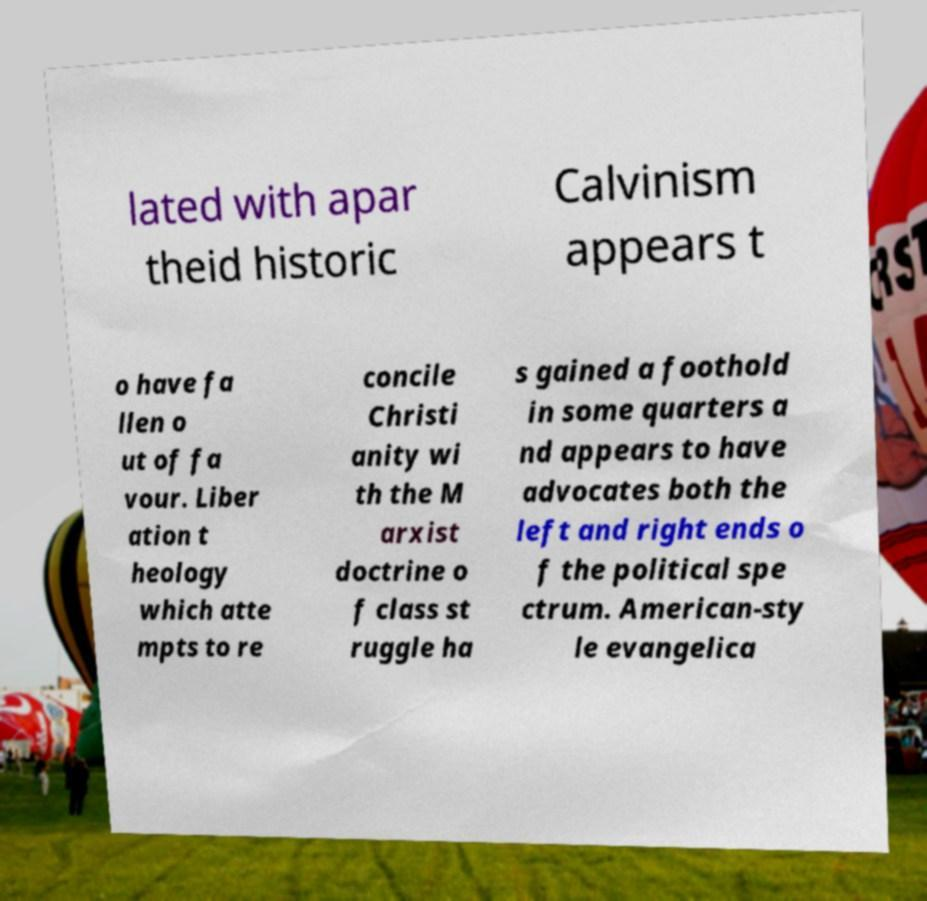For documentation purposes, I need the text within this image transcribed. Could you provide that? lated with apar theid historic Calvinism appears t o have fa llen o ut of fa vour. Liber ation t heology which atte mpts to re concile Christi anity wi th the M arxist doctrine o f class st ruggle ha s gained a foothold in some quarters a nd appears to have advocates both the left and right ends o f the political spe ctrum. American-sty le evangelica 